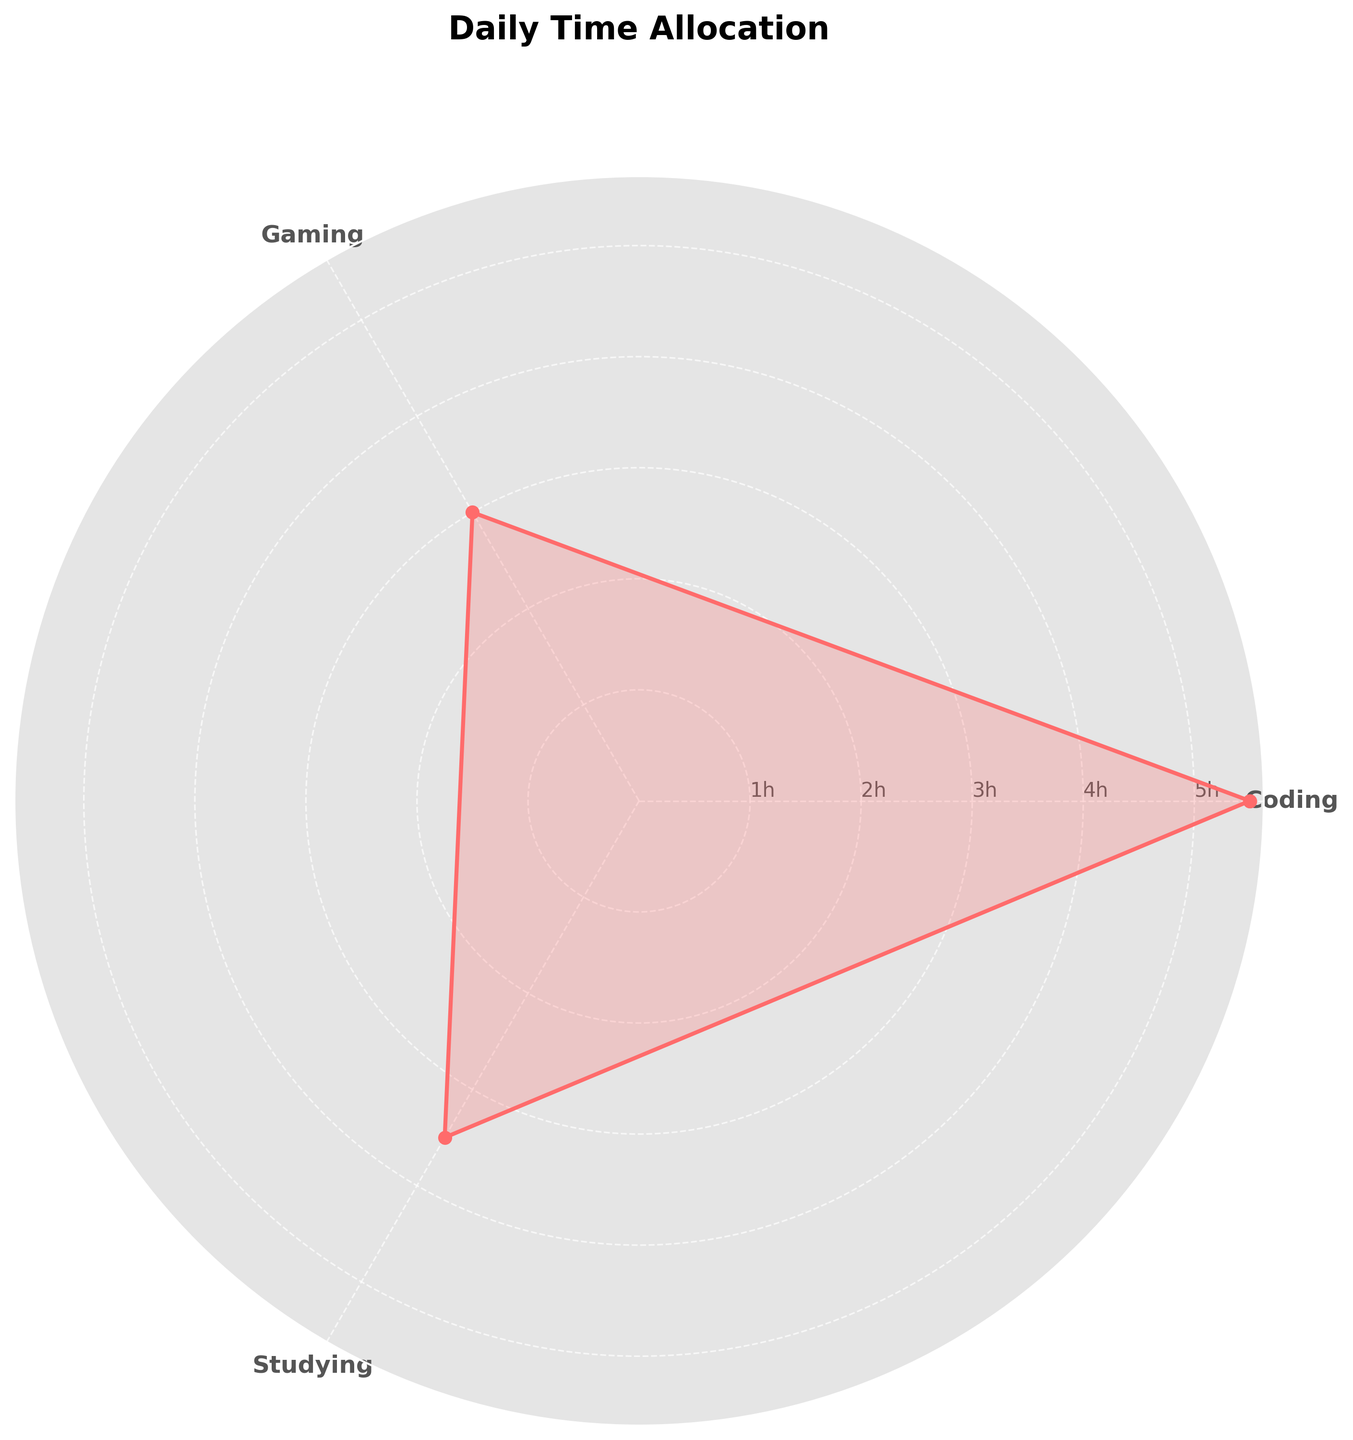what is the title of the rose chart? The title of the rose chart is typically displayed at the top of the figure in bold text. In this case, from the description provided, we know it is "Daily Time Allocation".
Answer: Daily Time Allocation how many categories are there in the rose chart? The categories are indicated by the labels on the plot. There are three unique categories in this chart.
Answer: 3 which category has the highest average time spent per day? The category with the highest value on the radial axis represents the highest average time spent per day. Coding shows the highest average value.
Answer: Coding what is the average time spent studying per day? The position of the Studying category on the radial axis shows its average value. The value is indicated by the plotted point falling on the circle representing 3.5 hours.
Answer: 3.5 hours what is the total average time spent on Gaming and Studying per day? Sum the average time spent on Gaming and Studying per day as indicated on the radial axis. Gaming is at 3 hours and Studying is at 3.5 hours. The total is 3.5 + 3 = 6.5.
Answer: 6.5 hours is the average time spent on Gaming greater than the average time spent Studying? Compare the average time spent on Gaming and Studying per day by looking at their respective positions on the radial axis. Gaming is at 3 hours and Studying is at 3.5 hours. Gaming is not greater.
Answer: No which category falls at the second highest average daily time allocation? The categories' values on the radial axis show the average time spent daily. The second-highest average is for Studying.
Answer: Studying what radial position does coding fall into? The radial position of each category is indicated by the angle corresponding to the category label. Coding falls directly at the highest point of the radial axis, indicating its highest value.
Answer: Top position 